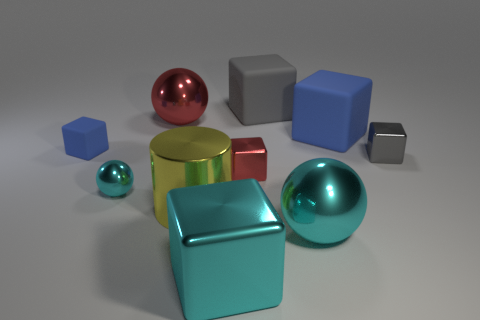Subtract all red balls. How many balls are left? 2 Subtract 2 balls. How many balls are left? 1 Subtract all cyan spheres. How many spheres are left? 1 Subtract all cyan balls. Subtract all yellow cylinders. How many balls are left? 1 Subtract all gray blocks. How many purple cylinders are left? 0 Subtract all small gray metal things. Subtract all small blue spheres. How many objects are left? 9 Add 3 tiny metallic blocks. How many tiny metallic blocks are left? 5 Add 3 small gray things. How many small gray things exist? 4 Subtract 1 gray blocks. How many objects are left? 9 Subtract all cylinders. How many objects are left? 9 